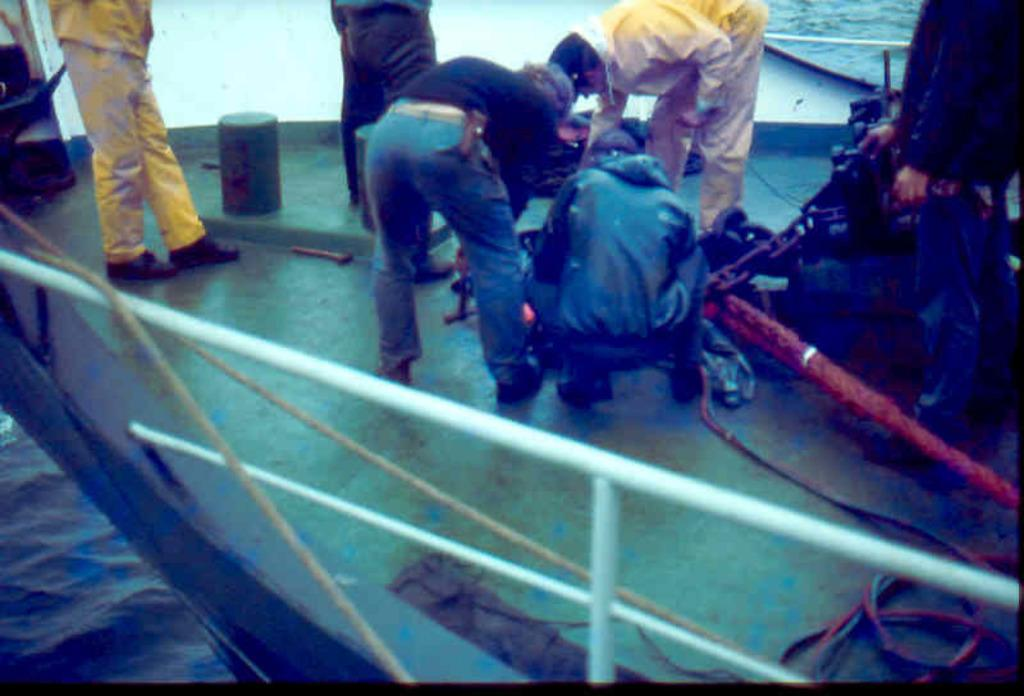What is the main subject of the image? The main subject of the image is a ship. What features can be seen on the ship? The ship has railings, ropes, and chains. Are there any people on the ship? Yes, there are people on the ship. What else can be seen on the ship besides the people? There are other unspecified things on the ship. What is visible at the bottom left corner of the image? Water is visible at the bottom left corner of the image. What type of rail does your aunt use to exercise in the image? There is no mention of an aunt or any exercise equipment in the image; it features a ship with people and various features. 